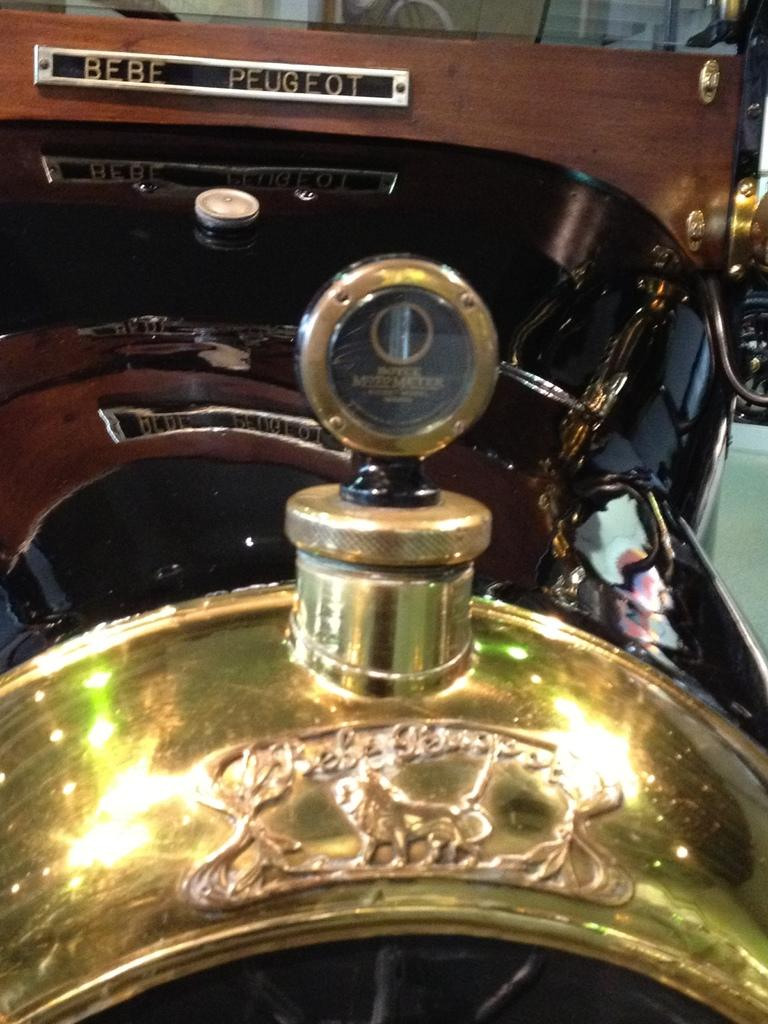What type of vehicle is visible in the image? The image shows the front part of a vehicle. Can you describe any specific features of the vehicle? Unfortunately, the provided facts do not give any details about the vehicle's features. Is there any indication of the vehicle's color or size? No, the color and size of the vehicle are not mentioned in the given facts. What type of church can be seen in the background of the image? There is no church present in the image; it only shows the front part of a vehicle. 